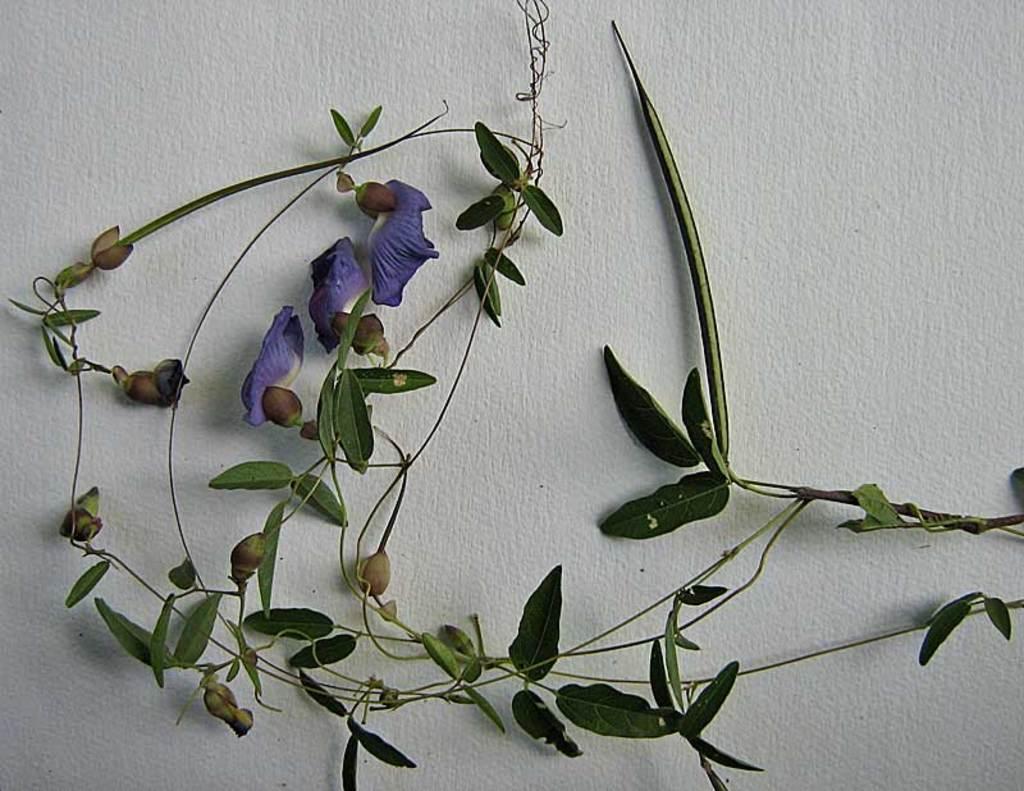In one or two sentences, can you explain what this image depicts? In this picture we can see leaves and flowers on the wall. 